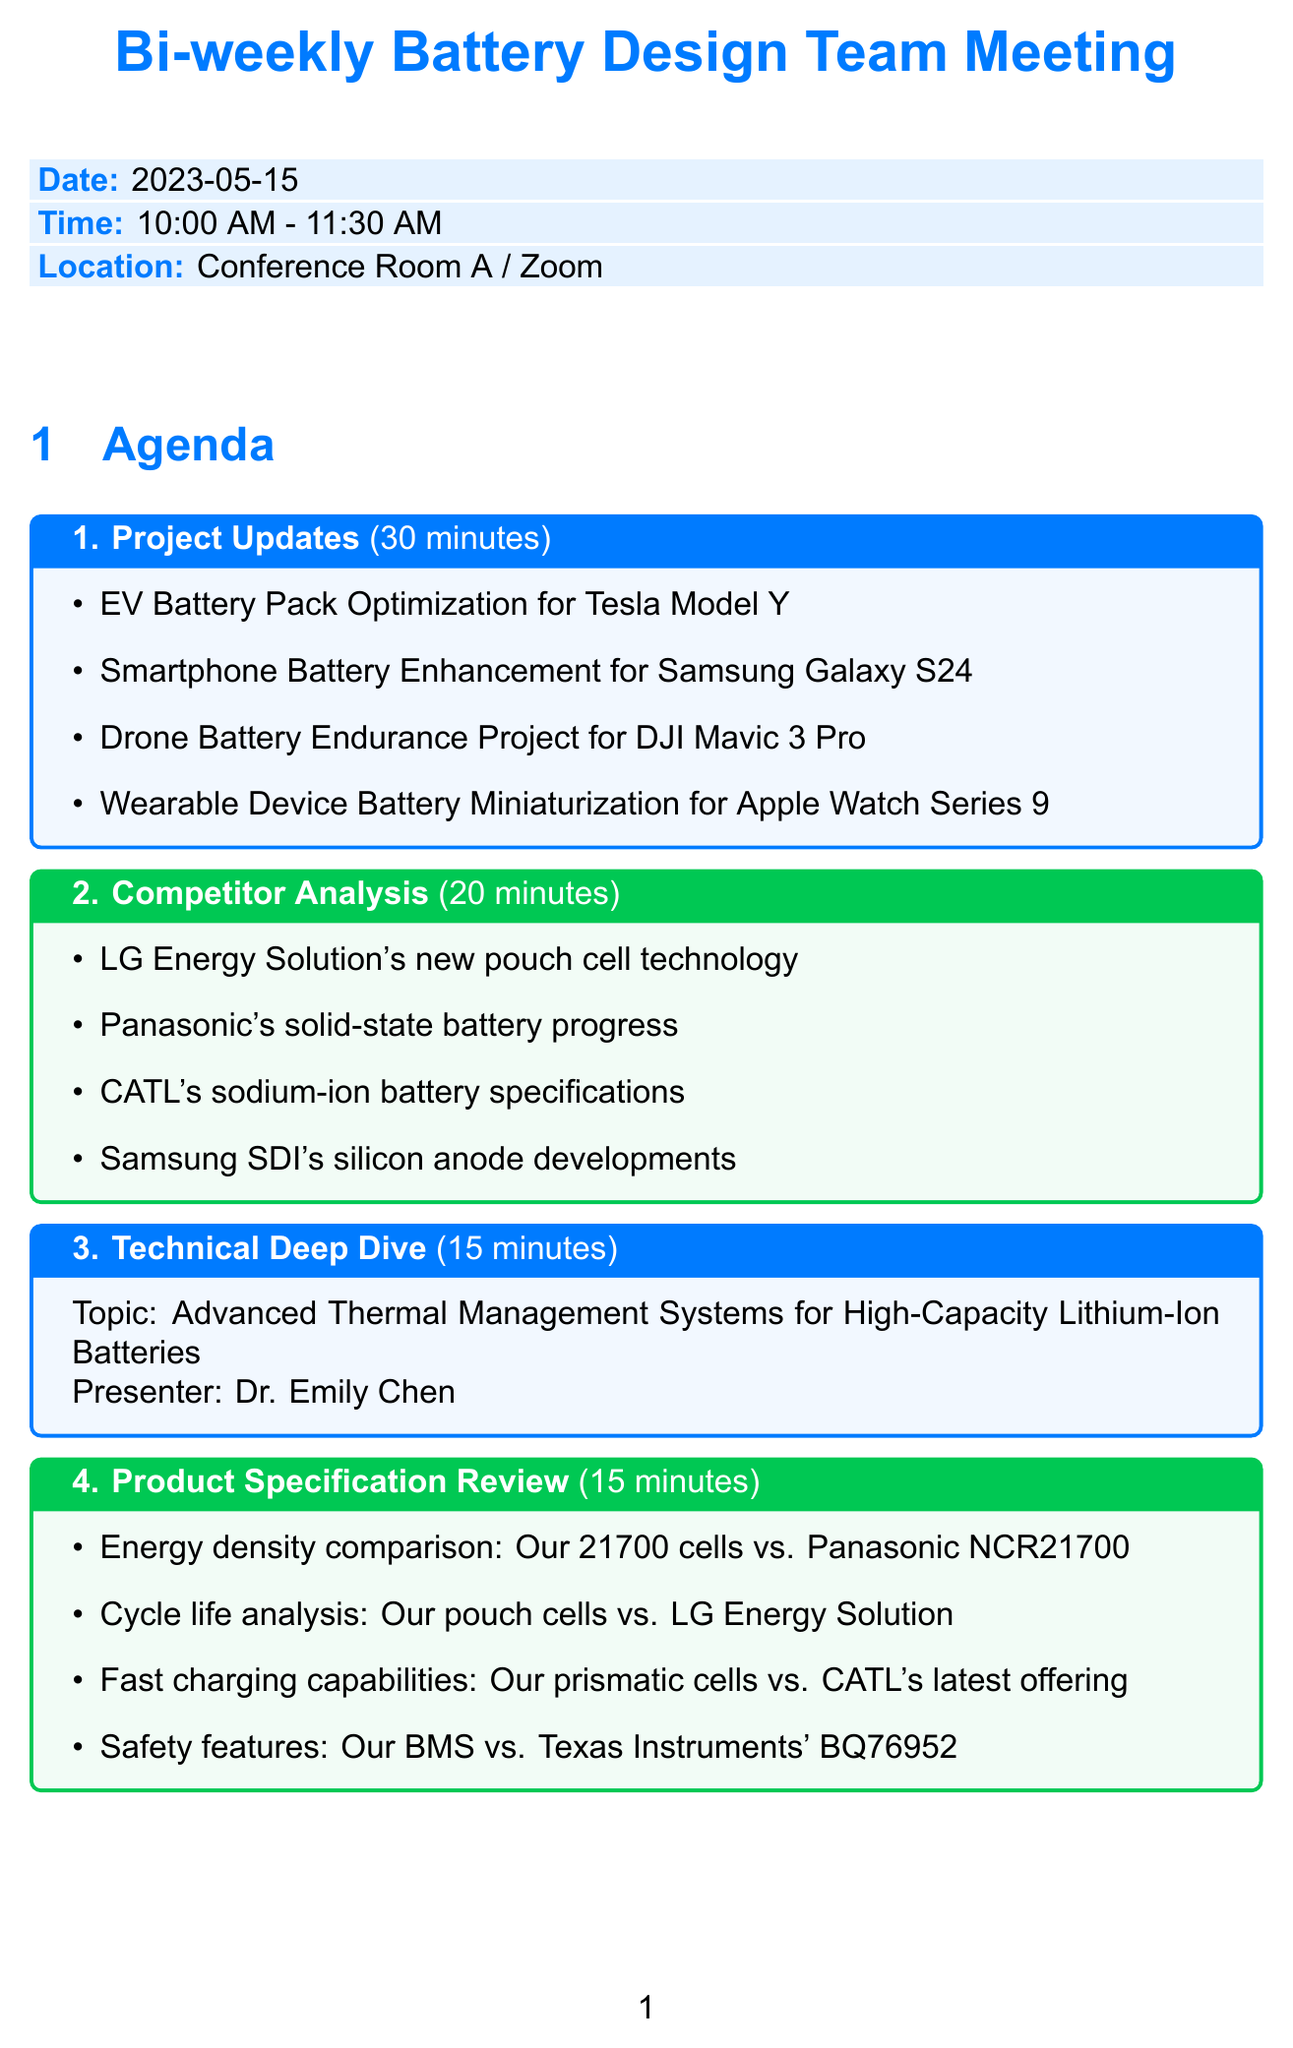What is the date of the meeting? The date is clearly stated in the document, which is "2023-05-15".
Answer: 2023-05-15 Who is the presenter for the Technical Deep Dive? The presenter is specified as "Dr. Emily Chen" in the agenda.
Answer: Dr. Emily Chen How long is the open discussion scheduled for? The duration for the open discussion is provided as "10 minutes" in the agenda.
Answer: 10 minutes What topic is discussed under Competitor Analysis? The document lists several topics under Competitor Analysis, including "LG Energy Solution's new pouch cell technology".
Answer: LG Energy Solution's new pouch cell technology What is one action item mentioned in the document? The document lists several action items, with one of them being "Update project timelines in Asana".
Answer: Update project timelines in Asana 